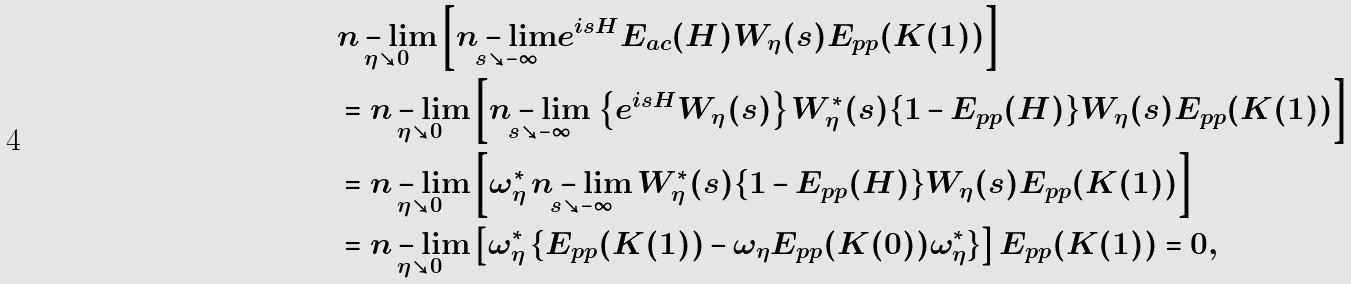<formula> <loc_0><loc_0><loc_500><loc_500>& \underset { \eta \searrow 0 } { n - \lim } \left [ \underset { s \searrow - \infty } { n - \lim } e ^ { i s H } E _ { a c } ( H ) W _ { \eta } ( s ) E _ { p p } ( K ( 1 ) ) \right ] \\ & = \underset { \eta \searrow 0 } { n - \lim } \left [ \underset { s \searrow - \infty } { n - \lim } \, \left \{ e ^ { i s H } W _ { \eta } ( s ) \right \} W _ { \eta } ^ { * } ( s ) \{ 1 - E _ { p p } ( H ) \} W _ { \eta } ( s ) E _ { p p } ( K ( 1 ) ) \right ] \\ & = \underset { \eta \searrow 0 } { n - \lim } \left [ \omega _ { \eta } ^ { * } \, \underset { s \searrow - \infty } { n - \lim } \, W _ { \eta } ^ { * } ( s ) \{ 1 - E _ { p p } ( H ) \} W _ { \eta } ( s ) E _ { p p } ( K ( 1 ) ) \right ] \\ & = \underset { \eta \searrow 0 } { n - \lim } \left [ \omega _ { \eta } ^ { * } \, \{ E _ { p p } ( K ( 1 ) ) - \omega _ { \eta } E _ { p p } ( K ( 0 ) ) \omega _ { \eta } ^ { * } \} \right ] E _ { p p } ( K ( 1 ) ) = 0 ,</formula> 